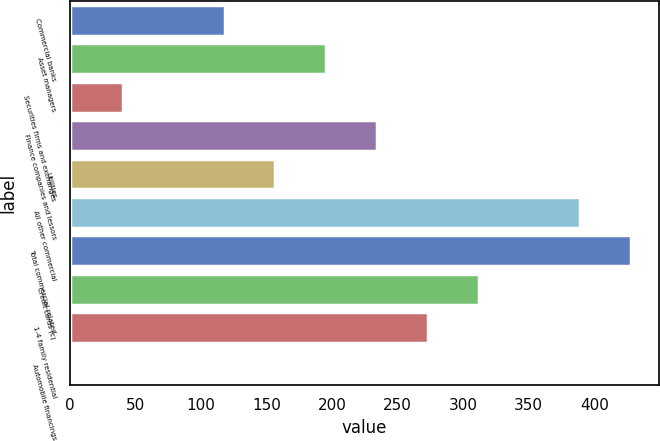<chart> <loc_0><loc_0><loc_500><loc_500><bar_chart><fcel>Commercial banks<fcel>Asset managers<fcel>Securities firms and exchanges<fcel>Finance companies and lessors<fcel>Utilities<fcel>All other commercial<fcel>Total commercial-related<fcel>Credit cards (c)<fcel>1-4 family residential<fcel>Automobile financings<nl><fcel>118.02<fcel>195.5<fcel>40.54<fcel>234.24<fcel>156.76<fcel>389.2<fcel>427.94<fcel>311.72<fcel>272.98<fcel>1.8<nl></chart> 